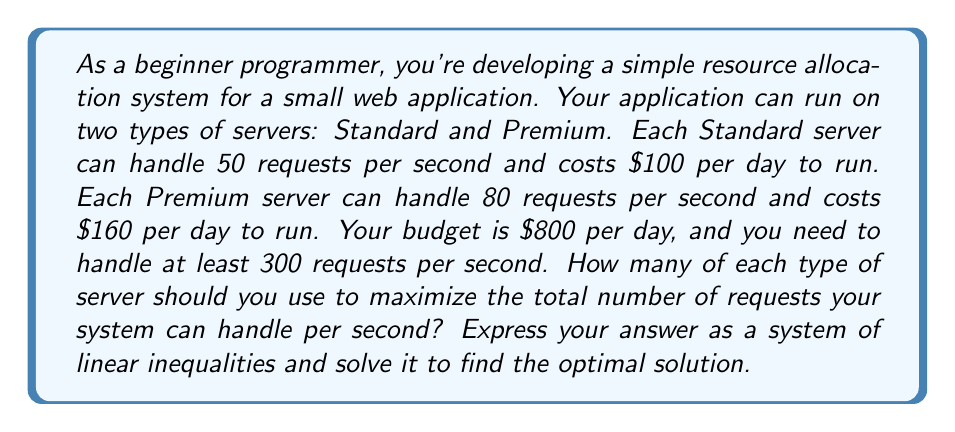Can you solve this math problem? Let's approach this step-by-step:

1) Define variables:
   Let $x$ = number of Standard servers
   Let $y$ = number of Premium servers

2) Set up the inequalities:

   a) Budget constraint: 
      $100x + 160y \leq 800$

   b) Minimum request handling requirement:
      $50x + 80y \geq 300$

   c) Non-negativity constraints:
      $x \geq 0$ and $y \geq 0$

3) Our objective is to maximize:
   $50x + 80y$

4) Let's graph these inequalities:

   [asy]
   import graph;
   size(200);
   
   xaxis("x", 0, 10, Arrow);
   yaxis("y", 0, 10, Arrow);
   
   draw((0,5)--(8,0), blue);
   draw((0,3.75)--(6,0), red);
   
   label("$100x + 160y = 800$", (4,2.5), blue);
   label("$50x + 80y = 300$", (3,1.875), red);
   
   fill((0,3.75)--(3.75,1.875)--(5,0)--(0,0)--cycle, palegreen+opacity(0.2));
   
   dot((0,5));
   dot((8,0));
   dot((0,3.75));
   dot((6,0));
   dot((3.75,1.875));
   [/asy]

5) The feasible region is the shaded area. The optimal solution will be at one of the corner points of this region.

6) The corner points are:
   (0, 3.75), (3.75, 1.875), (5, 0)

7) Let's evaluate our objective function at each point:
   At (0, 3.75): 50(0) + 80(3.75) = 300
   At (3.75, 1.875): 50(3.75) + 80(1.875) = 337.5
   At (5, 0): 50(5) + 80(0) = 250

8) The maximum value is at (3.75, 1.875), but we need integer solutions.

9) Checking nearby integer points:
   (3, 2): 50(3) + 80(2) = 310, cost = $620
   (4, 1): 50(4) + 80(1) = 280, cost = $560

10) Therefore, the optimal integer solution is (3, 2).
Answer: The optimal solution is to use 3 Standard servers and 2 Premium servers. This will handle $50(3) + 80(2) = 310$ requests per second, which meets the minimum requirement of 300 requests per second. The daily cost will be $100(3) + $160(2) = $620, which is within the $800 budget. 